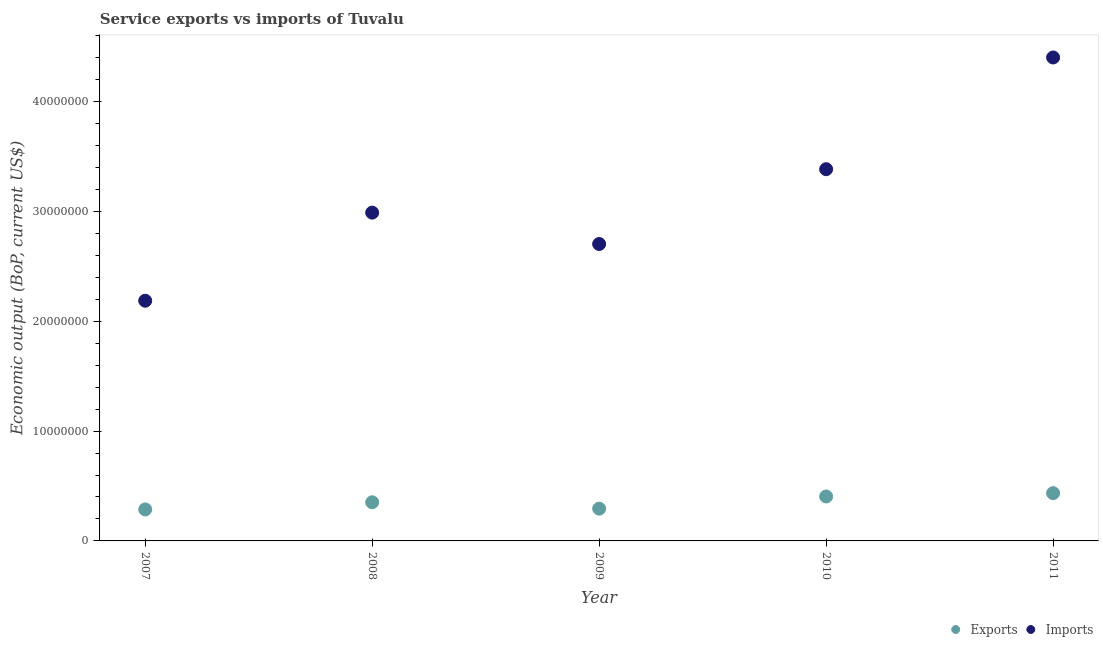Is the number of dotlines equal to the number of legend labels?
Keep it short and to the point. Yes. What is the amount of service imports in 2009?
Ensure brevity in your answer.  2.70e+07. Across all years, what is the maximum amount of service exports?
Your answer should be compact. 4.35e+06. Across all years, what is the minimum amount of service exports?
Offer a terse response. 2.87e+06. What is the total amount of service exports in the graph?
Provide a succinct answer. 1.77e+07. What is the difference between the amount of service exports in 2007 and that in 2011?
Ensure brevity in your answer.  -1.48e+06. What is the difference between the amount of service exports in 2011 and the amount of service imports in 2008?
Provide a short and direct response. -2.55e+07. What is the average amount of service imports per year?
Ensure brevity in your answer.  3.13e+07. In the year 2010, what is the difference between the amount of service imports and amount of service exports?
Give a very brief answer. 2.98e+07. In how many years, is the amount of service exports greater than 42000000 US$?
Offer a terse response. 0. What is the ratio of the amount of service exports in 2009 to that in 2011?
Provide a succinct answer. 0.68. Is the amount of service imports in 2007 less than that in 2011?
Provide a succinct answer. Yes. Is the difference between the amount of service imports in 2007 and 2008 greater than the difference between the amount of service exports in 2007 and 2008?
Your response must be concise. No. What is the difference between the highest and the second highest amount of service imports?
Give a very brief answer. 1.02e+07. What is the difference between the highest and the lowest amount of service exports?
Your answer should be very brief. 1.48e+06. Is the sum of the amount of service exports in 2008 and 2011 greater than the maximum amount of service imports across all years?
Provide a succinct answer. No. Does the amount of service exports monotonically increase over the years?
Keep it short and to the point. No. Is the amount of service exports strictly less than the amount of service imports over the years?
Your answer should be very brief. Yes. How many dotlines are there?
Ensure brevity in your answer.  2. How many years are there in the graph?
Make the answer very short. 5. Does the graph contain grids?
Ensure brevity in your answer.  No. Where does the legend appear in the graph?
Keep it short and to the point. Bottom right. How many legend labels are there?
Ensure brevity in your answer.  2. What is the title of the graph?
Make the answer very short. Service exports vs imports of Tuvalu. Does "Subsidies" appear as one of the legend labels in the graph?
Provide a short and direct response. No. What is the label or title of the X-axis?
Offer a very short reply. Year. What is the label or title of the Y-axis?
Your answer should be compact. Economic output (BoP, current US$). What is the Economic output (BoP, current US$) of Exports in 2007?
Provide a succinct answer. 2.87e+06. What is the Economic output (BoP, current US$) in Imports in 2007?
Provide a succinct answer. 2.19e+07. What is the Economic output (BoP, current US$) of Exports in 2008?
Your answer should be compact. 3.52e+06. What is the Economic output (BoP, current US$) of Imports in 2008?
Your answer should be very brief. 2.99e+07. What is the Economic output (BoP, current US$) of Exports in 2009?
Your response must be concise. 2.94e+06. What is the Economic output (BoP, current US$) of Imports in 2009?
Offer a very short reply. 2.70e+07. What is the Economic output (BoP, current US$) of Exports in 2010?
Make the answer very short. 4.05e+06. What is the Economic output (BoP, current US$) in Imports in 2010?
Your answer should be compact. 3.38e+07. What is the Economic output (BoP, current US$) of Exports in 2011?
Keep it short and to the point. 4.35e+06. What is the Economic output (BoP, current US$) in Imports in 2011?
Provide a short and direct response. 4.40e+07. Across all years, what is the maximum Economic output (BoP, current US$) in Exports?
Your response must be concise. 4.35e+06. Across all years, what is the maximum Economic output (BoP, current US$) of Imports?
Provide a short and direct response. 4.40e+07. Across all years, what is the minimum Economic output (BoP, current US$) of Exports?
Your answer should be compact. 2.87e+06. Across all years, what is the minimum Economic output (BoP, current US$) of Imports?
Provide a short and direct response. 2.19e+07. What is the total Economic output (BoP, current US$) of Exports in the graph?
Your response must be concise. 1.77e+07. What is the total Economic output (BoP, current US$) of Imports in the graph?
Give a very brief answer. 1.57e+08. What is the difference between the Economic output (BoP, current US$) in Exports in 2007 and that in 2008?
Make the answer very short. -6.52e+05. What is the difference between the Economic output (BoP, current US$) in Imports in 2007 and that in 2008?
Offer a terse response. -8.02e+06. What is the difference between the Economic output (BoP, current US$) in Exports in 2007 and that in 2009?
Provide a short and direct response. -7.31e+04. What is the difference between the Economic output (BoP, current US$) of Imports in 2007 and that in 2009?
Make the answer very short. -5.16e+06. What is the difference between the Economic output (BoP, current US$) in Exports in 2007 and that in 2010?
Give a very brief answer. -1.18e+06. What is the difference between the Economic output (BoP, current US$) in Imports in 2007 and that in 2010?
Ensure brevity in your answer.  -1.20e+07. What is the difference between the Economic output (BoP, current US$) of Exports in 2007 and that in 2011?
Your answer should be compact. -1.48e+06. What is the difference between the Economic output (BoP, current US$) of Imports in 2007 and that in 2011?
Provide a succinct answer. -2.21e+07. What is the difference between the Economic output (BoP, current US$) of Exports in 2008 and that in 2009?
Your answer should be compact. 5.79e+05. What is the difference between the Economic output (BoP, current US$) of Imports in 2008 and that in 2009?
Keep it short and to the point. 2.86e+06. What is the difference between the Economic output (BoP, current US$) of Exports in 2008 and that in 2010?
Offer a very short reply. -5.28e+05. What is the difference between the Economic output (BoP, current US$) in Imports in 2008 and that in 2010?
Your response must be concise. -3.95e+06. What is the difference between the Economic output (BoP, current US$) in Exports in 2008 and that in 2011?
Provide a succinct answer. -8.28e+05. What is the difference between the Economic output (BoP, current US$) in Imports in 2008 and that in 2011?
Your answer should be compact. -1.41e+07. What is the difference between the Economic output (BoP, current US$) in Exports in 2009 and that in 2010?
Make the answer very short. -1.11e+06. What is the difference between the Economic output (BoP, current US$) of Imports in 2009 and that in 2010?
Your answer should be very brief. -6.81e+06. What is the difference between the Economic output (BoP, current US$) in Exports in 2009 and that in 2011?
Keep it short and to the point. -1.41e+06. What is the difference between the Economic output (BoP, current US$) of Imports in 2009 and that in 2011?
Provide a short and direct response. -1.70e+07. What is the difference between the Economic output (BoP, current US$) of Exports in 2010 and that in 2011?
Offer a very short reply. -3.00e+05. What is the difference between the Economic output (BoP, current US$) in Imports in 2010 and that in 2011?
Your answer should be compact. -1.02e+07. What is the difference between the Economic output (BoP, current US$) of Exports in 2007 and the Economic output (BoP, current US$) of Imports in 2008?
Provide a short and direct response. -2.70e+07. What is the difference between the Economic output (BoP, current US$) of Exports in 2007 and the Economic output (BoP, current US$) of Imports in 2009?
Your answer should be compact. -2.42e+07. What is the difference between the Economic output (BoP, current US$) in Exports in 2007 and the Economic output (BoP, current US$) in Imports in 2010?
Provide a succinct answer. -3.10e+07. What is the difference between the Economic output (BoP, current US$) of Exports in 2007 and the Economic output (BoP, current US$) of Imports in 2011?
Keep it short and to the point. -4.11e+07. What is the difference between the Economic output (BoP, current US$) in Exports in 2008 and the Economic output (BoP, current US$) in Imports in 2009?
Your response must be concise. -2.35e+07. What is the difference between the Economic output (BoP, current US$) in Exports in 2008 and the Economic output (BoP, current US$) in Imports in 2010?
Offer a terse response. -3.03e+07. What is the difference between the Economic output (BoP, current US$) of Exports in 2008 and the Economic output (BoP, current US$) of Imports in 2011?
Ensure brevity in your answer.  -4.05e+07. What is the difference between the Economic output (BoP, current US$) in Exports in 2009 and the Economic output (BoP, current US$) in Imports in 2010?
Your answer should be compact. -3.09e+07. What is the difference between the Economic output (BoP, current US$) in Exports in 2009 and the Economic output (BoP, current US$) in Imports in 2011?
Your response must be concise. -4.11e+07. What is the difference between the Economic output (BoP, current US$) in Exports in 2010 and the Economic output (BoP, current US$) in Imports in 2011?
Provide a short and direct response. -4.00e+07. What is the average Economic output (BoP, current US$) of Exports per year?
Ensure brevity in your answer.  3.54e+06. What is the average Economic output (BoP, current US$) in Imports per year?
Your answer should be very brief. 3.13e+07. In the year 2007, what is the difference between the Economic output (BoP, current US$) of Exports and Economic output (BoP, current US$) of Imports?
Make the answer very short. -1.90e+07. In the year 2008, what is the difference between the Economic output (BoP, current US$) of Exports and Economic output (BoP, current US$) of Imports?
Provide a succinct answer. -2.64e+07. In the year 2009, what is the difference between the Economic output (BoP, current US$) of Exports and Economic output (BoP, current US$) of Imports?
Provide a short and direct response. -2.41e+07. In the year 2010, what is the difference between the Economic output (BoP, current US$) of Exports and Economic output (BoP, current US$) of Imports?
Keep it short and to the point. -2.98e+07. In the year 2011, what is the difference between the Economic output (BoP, current US$) in Exports and Economic output (BoP, current US$) in Imports?
Give a very brief answer. -3.97e+07. What is the ratio of the Economic output (BoP, current US$) in Exports in 2007 to that in 2008?
Your response must be concise. 0.81. What is the ratio of the Economic output (BoP, current US$) in Imports in 2007 to that in 2008?
Your answer should be very brief. 0.73. What is the ratio of the Economic output (BoP, current US$) of Exports in 2007 to that in 2009?
Offer a terse response. 0.98. What is the ratio of the Economic output (BoP, current US$) in Imports in 2007 to that in 2009?
Provide a succinct answer. 0.81. What is the ratio of the Economic output (BoP, current US$) in Exports in 2007 to that in 2010?
Ensure brevity in your answer.  0.71. What is the ratio of the Economic output (BoP, current US$) of Imports in 2007 to that in 2010?
Your answer should be very brief. 0.65. What is the ratio of the Economic output (BoP, current US$) of Exports in 2007 to that in 2011?
Offer a terse response. 0.66. What is the ratio of the Economic output (BoP, current US$) in Imports in 2007 to that in 2011?
Offer a very short reply. 0.5. What is the ratio of the Economic output (BoP, current US$) in Exports in 2008 to that in 2009?
Provide a succinct answer. 1.2. What is the ratio of the Economic output (BoP, current US$) in Imports in 2008 to that in 2009?
Provide a short and direct response. 1.11. What is the ratio of the Economic output (BoP, current US$) of Exports in 2008 to that in 2010?
Your answer should be very brief. 0.87. What is the ratio of the Economic output (BoP, current US$) in Imports in 2008 to that in 2010?
Give a very brief answer. 0.88. What is the ratio of the Economic output (BoP, current US$) in Exports in 2008 to that in 2011?
Your response must be concise. 0.81. What is the ratio of the Economic output (BoP, current US$) in Imports in 2008 to that in 2011?
Your answer should be very brief. 0.68. What is the ratio of the Economic output (BoP, current US$) in Exports in 2009 to that in 2010?
Your response must be concise. 0.73. What is the ratio of the Economic output (BoP, current US$) in Imports in 2009 to that in 2010?
Give a very brief answer. 0.8. What is the ratio of the Economic output (BoP, current US$) of Exports in 2009 to that in 2011?
Your answer should be very brief. 0.68. What is the ratio of the Economic output (BoP, current US$) in Imports in 2009 to that in 2011?
Your answer should be very brief. 0.61. What is the ratio of the Economic output (BoP, current US$) of Exports in 2010 to that in 2011?
Offer a terse response. 0.93. What is the ratio of the Economic output (BoP, current US$) of Imports in 2010 to that in 2011?
Ensure brevity in your answer.  0.77. What is the difference between the highest and the second highest Economic output (BoP, current US$) in Exports?
Provide a short and direct response. 3.00e+05. What is the difference between the highest and the second highest Economic output (BoP, current US$) in Imports?
Make the answer very short. 1.02e+07. What is the difference between the highest and the lowest Economic output (BoP, current US$) in Exports?
Ensure brevity in your answer.  1.48e+06. What is the difference between the highest and the lowest Economic output (BoP, current US$) of Imports?
Make the answer very short. 2.21e+07. 